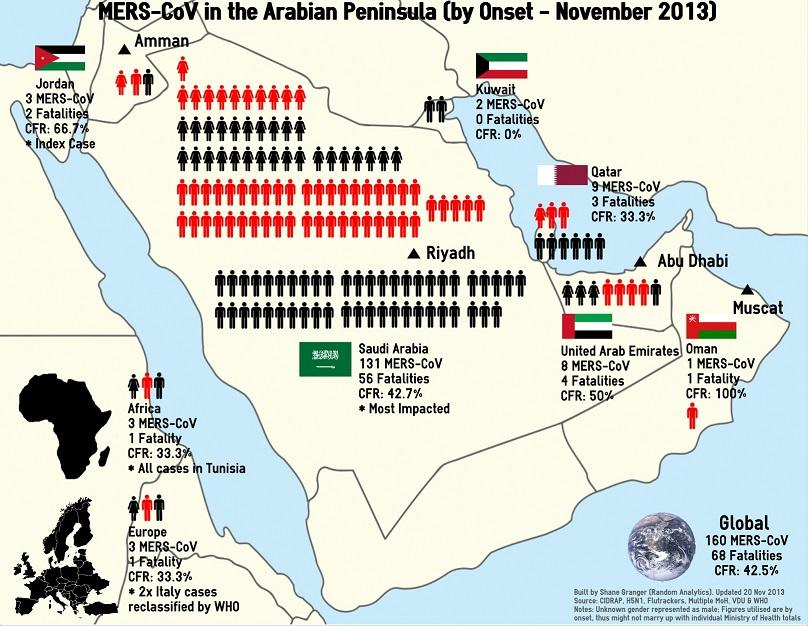Outline some significant characteristics in this image. As of November 2013, the global impact of the MERS virus had affected 160 people worldwide since its onset. As of November 2013, a total of 4 deaths were reported to have been caused by the Middle East Respiratory Syndrome Coronavirus (MERS-CoV) in the United Arab Emirates (UAE). As of November 2013, Oman in the Arabian Peninsula has reported a 100 percent Case-Fatality Ratio (CFR) due to the MERS virus, making it the country with the highest number of deaths related to the virus in the region. As of November 2013, a total of 3 individuals in Europe had been affected by the MERS virus since its onset. It is known that Saudi Arabia is the country in the Arabian Peninsula that has been significantly affected by the MERS virus since the outbreak began in November 2013. 